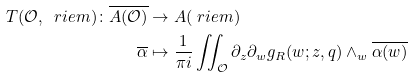<formula> <loc_0><loc_0><loc_500><loc_500>T ( \mathcal { O } , \ r i e m ) \colon \overline { A ( \mathcal { O } ) } & \rightarrow A ( \ r i e m ) \\ \overline { \alpha } & \mapsto \frac { 1 } { \pi i } \iint _ { \mathcal { O } } \partial _ { z } \partial _ { w } g _ { R } ( w ; z , q ) \wedge _ { w } \overline { \alpha ( w ) }</formula> 